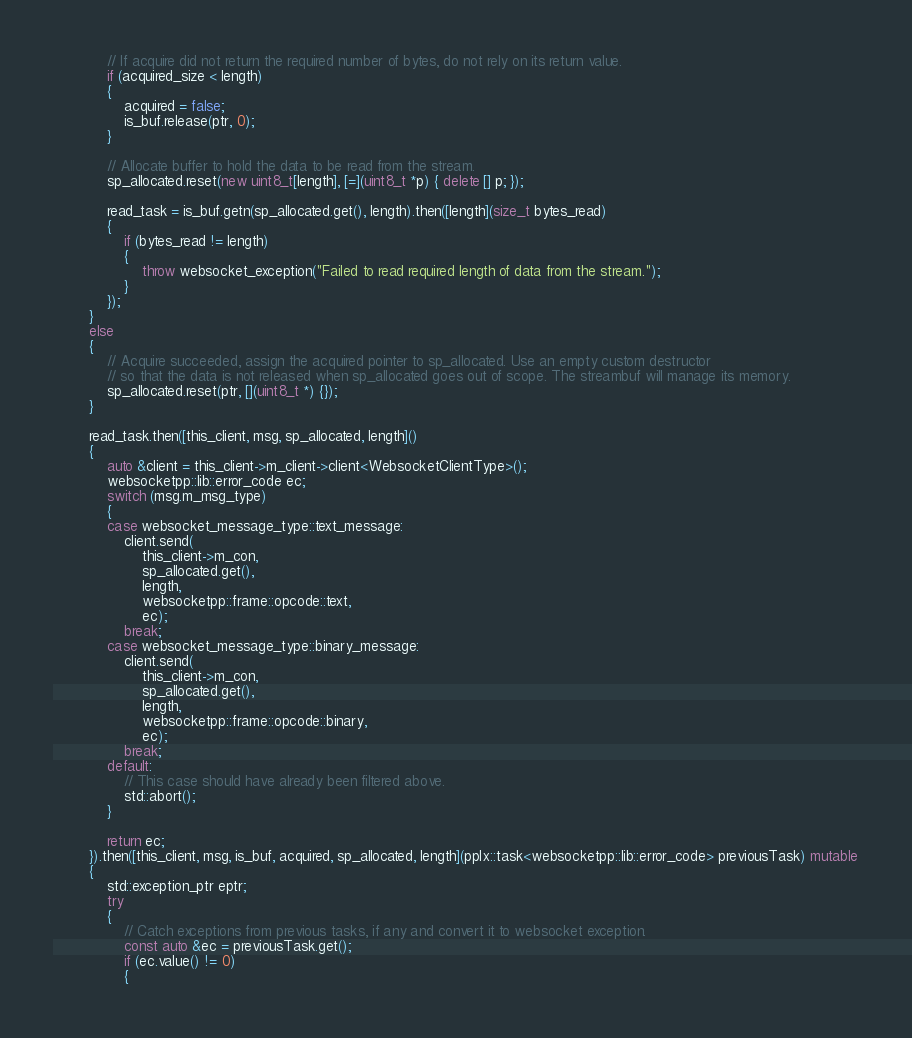<code> <loc_0><loc_0><loc_500><loc_500><_C++_>            // If acquire did not return the required number of bytes, do not rely on its return value.
            if (acquired_size < length)
            {
                acquired = false;
                is_buf.release(ptr, 0);
            }

            // Allocate buffer to hold the data to be read from the stream.
            sp_allocated.reset(new uint8_t[length], [=](uint8_t *p) { delete [] p; });

            read_task = is_buf.getn(sp_allocated.get(), length).then([length](size_t bytes_read)
            {
                if (bytes_read != length)
                {
                    throw websocket_exception("Failed to read required length of data from the stream.");
                }
            });
        }
        else
        {
            // Acquire succeeded, assign the acquired pointer to sp_allocated. Use an empty custom destructor
            // so that the data is not released when sp_allocated goes out of scope. The streambuf will manage its memory.
            sp_allocated.reset(ptr, [](uint8_t *) {});
        }

        read_task.then([this_client, msg, sp_allocated, length]()
        {
        	auto &client = this_client->m_client->client<WebsocketClientType>();
            websocketpp::lib::error_code ec;
            switch (msg.m_msg_type)
            {
            case websocket_message_type::text_message:
                client.send(
                    this_client->m_con,
                    sp_allocated.get(),
                    length,
                    websocketpp::frame::opcode::text,
                    ec);
                break;
            case websocket_message_type::binary_message:
                client.send(
                    this_client->m_con,
                    sp_allocated.get(),
                    length,
                    websocketpp::frame::opcode::binary,
                    ec);
                break;
            default:
                // This case should have already been filtered above.
                std::abort();
            }

            return ec;
        }).then([this_client, msg, is_buf, acquired, sp_allocated, length](pplx::task<websocketpp::lib::error_code> previousTask) mutable
        {
            std::exception_ptr eptr;
            try
            {
                // Catch exceptions from previous tasks, if any and convert it to websocket exception.
                const auto &ec = previousTask.get();
                if (ec.value() != 0)
                {</code> 